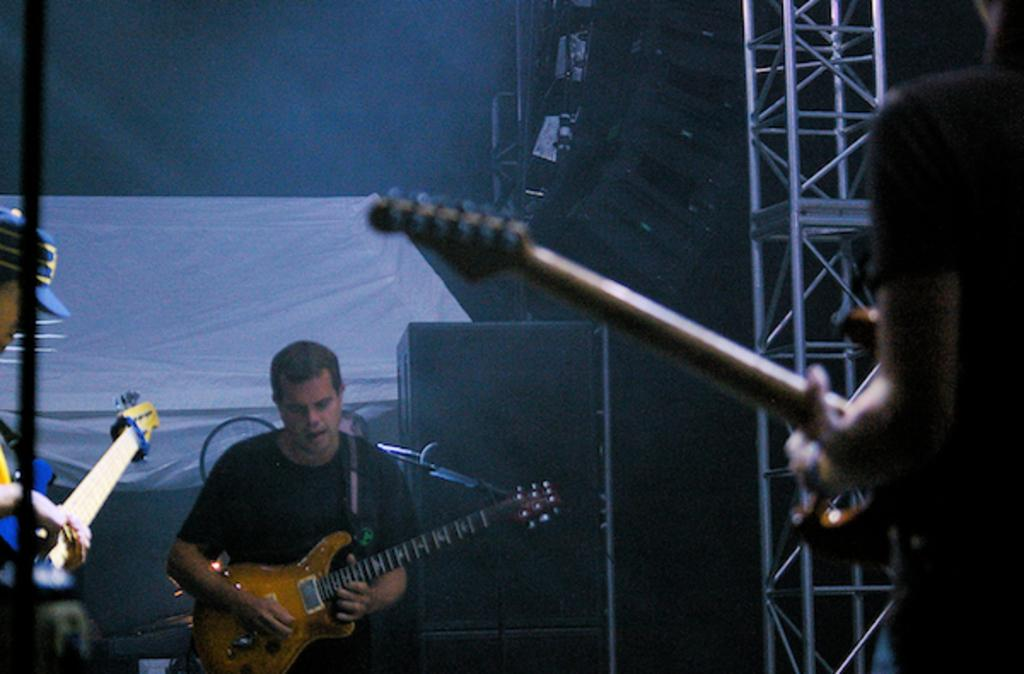How many people are in the image? There are three persons in the image. What are the three persons doing in the image? Each of the three persons is playing a guitar. How many kittens can be seen playing with the liquid on the mountain in the image? There are no kittens, liquid, or mountains present in the image. 